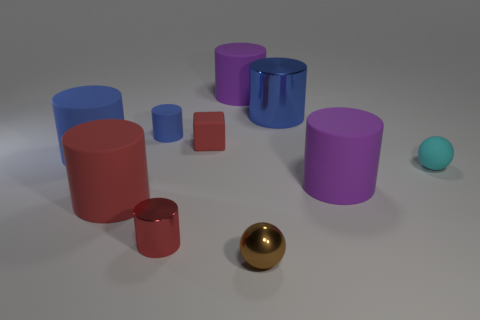Subtract all blue cylinders. How many were subtracted if there are1blue cylinders left? 2 Subtract all red matte cylinders. How many cylinders are left? 6 Subtract all purple cylinders. How many cylinders are left? 5 Subtract 1 spheres. How many spheres are left? 1 Subtract all purple balls. How many blue cylinders are left? 3 Subtract all brown cylinders. Subtract all gray cubes. How many cylinders are left? 7 Subtract all small balls. Subtract all red rubber blocks. How many objects are left? 7 Add 2 blue objects. How many blue objects are left? 5 Add 3 tiny red metal things. How many tiny red metal things exist? 4 Subtract 0 cyan cylinders. How many objects are left? 10 